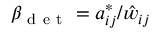<formula> <loc_0><loc_0><loc_500><loc_500>\beta _ { d e t } = a _ { i j } ^ { * } / \hat { w } _ { i j }</formula> 